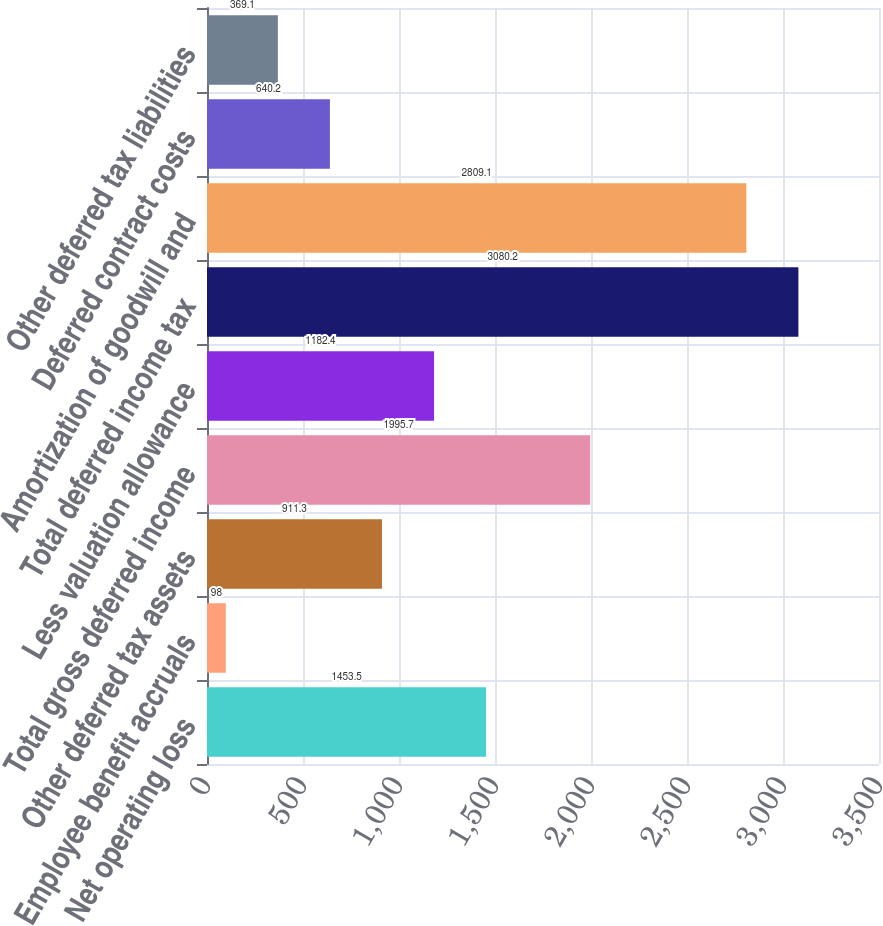Convert chart. <chart><loc_0><loc_0><loc_500><loc_500><bar_chart><fcel>Net operating loss<fcel>Employee benefit accruals<fcel>Other deferred tax assets<fcel>Total gross deferred income<fcel>Less valuation allowance<fcel>Total deferred income tax<fcel>Amortization of goodwill and<fcel>Deferred contract costs<fcel>Other deferred tax liabilities<nl><fcel>1453.5<fcel>98<fcel>911.3<fcel>1995.7<fcel>1182.4<fcel>3080.2<fcel>2809.1<fcel>640.2<fcel>369.1<nl></chart> 